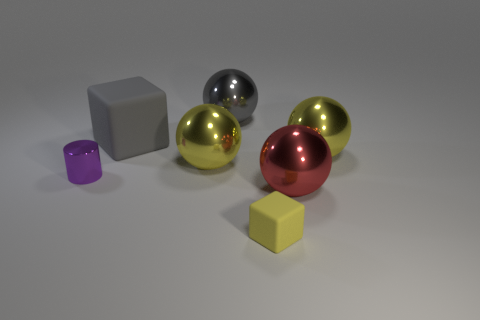Subtract all gray balls. How many balls are left? 3 Subtract all gray blocks. How many yellow spheres are left? 2 Add 2 big gray matte objects. How many objects exist? 9 Subtract all gray spheres. How many spheres are left? 3 Subtract all blocks. How many objects are left? 5 Subtract all blue balls. Subtract all blue cubes. How many balls are left? 4 Add 4 yellow rubber blocks. How many yellow rubber blocks exist? 5 Subtract 0 purple blocks. How many objects are left? 7 Subtract all tiny yellow matte cylinders. Subtract all tiny metallic cylinders. How many objects are left? 6 Add 2 small rubber blocks. How many small rubber blocks are left? 3 